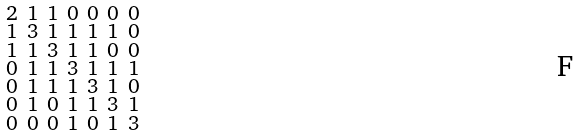<formula> <loc_0><loc_0><loc_500><loc_500>\begin{smallmatrix} 2 & 1 & 1 & 0 & 0 & 0 & 0 \\ 1 & 3 & 1 & 1 & 1 & 1 & 0 \\ 1 & 1 & 3 & 1 & 1 & 0 & 0 \\ 0 & 1 & 1 & 3 & 1 & 1 & 1 \\ 0 & 1 & 1 & 1 & 3 & 1 & 0 \\ 0 & 1 & 0 & 1 & 1 & 3 & 1 \\ 0 & 0 & 0 & 1 & 0 & 1 & 3 \end{smallmatrix}</formula> 